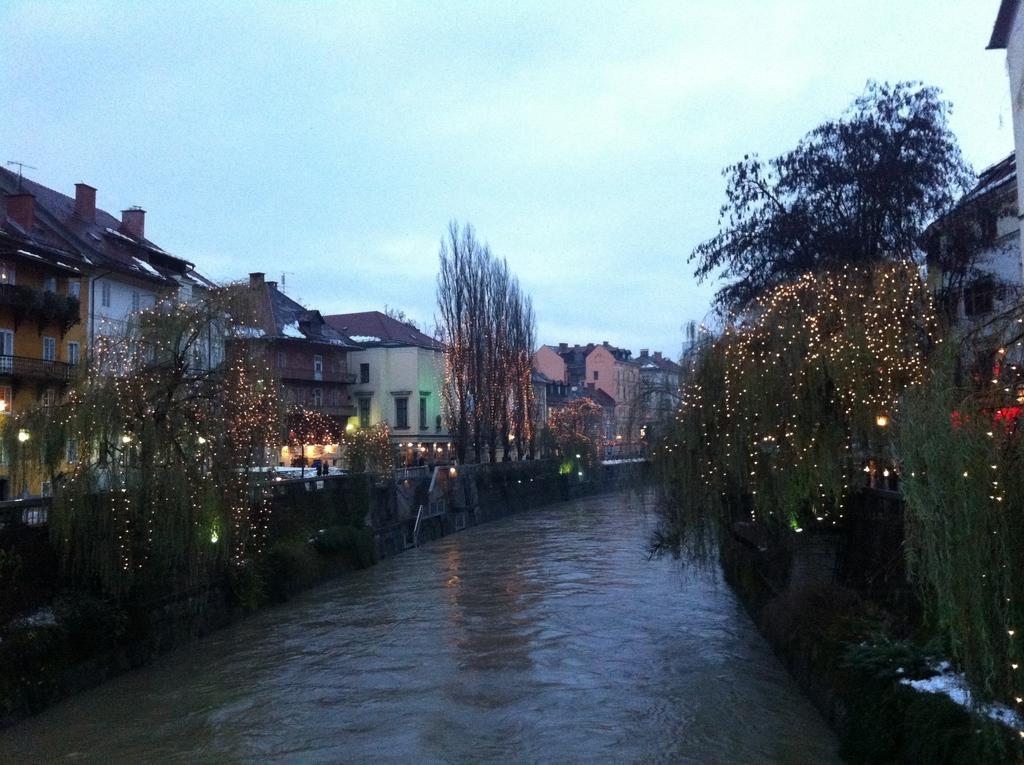Describe this image in one or two sentences. In this image we can see water, trees. buildings, road, lights, sky and clouds. 